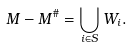<formula> <loc_0><loc_0><loc_500><loc_500>M - M ^ { \# } = \bigcup _ { i \in S } W _ { i } .</formula> 